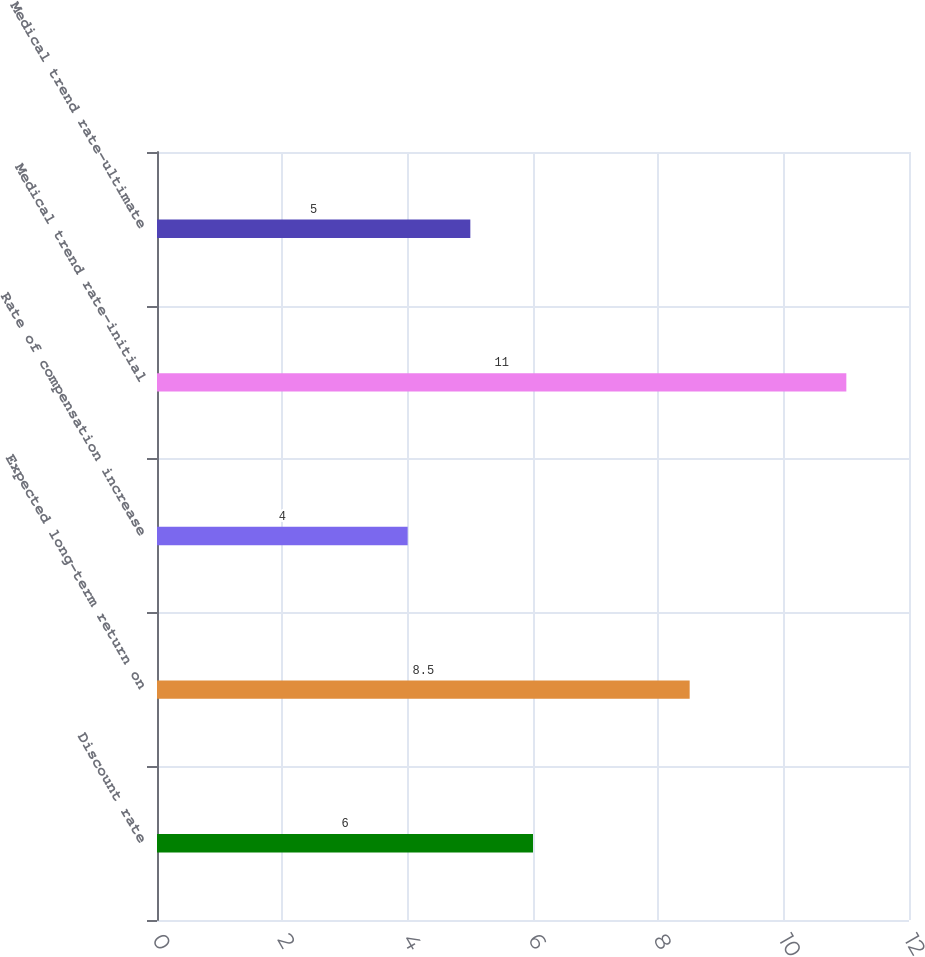Convert chart to OTSL. <chart><loc_0><loc_0><loc_500><loc_500><bar_chart><fcel>Discount rate<fcel>Expected long-term return on<fcel>Rate of compensation increase<fcel>Medical trend rate-initial<fcel>Medical trend rate-ultimate<nl><fcel>6<fcel>8.5<fcel>4<fcel>11<fcel>5<nl></chart> 